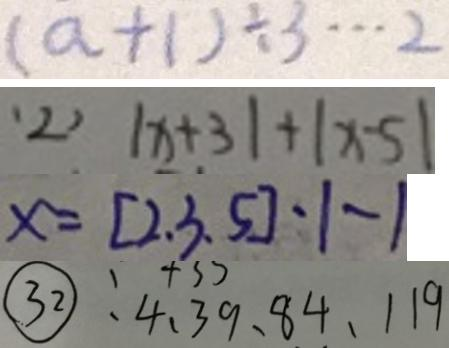Convert formula to latex. <formula><loc_0><loc_0><loc_500><loc_500>( a + 1 ) \div 3 \cdots 2 
 ( 2 ) \vert x + 3 \vert + \vert x - 5 \vert 
 x = [ 2 , 3 , 5 ] - 1 - 1 
 \textcircled { 3 2 } : 4 、 3 9 、 8 4 、 1 1 9</formula> 